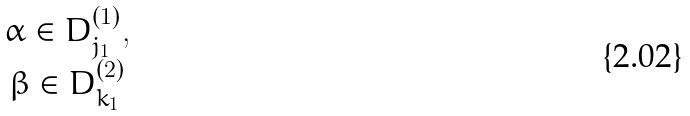Convert formula to latex. <formula><loc_0><loc_0><loc_500><loc_500>\begin{matrix} \alpha \in D _ { j _ { 1 } } ^ { ( 1 ) } , \\ \beta \in D _ { k _ { 1 } } ^ { ( 2 ) } \end{matrix}</formula> 